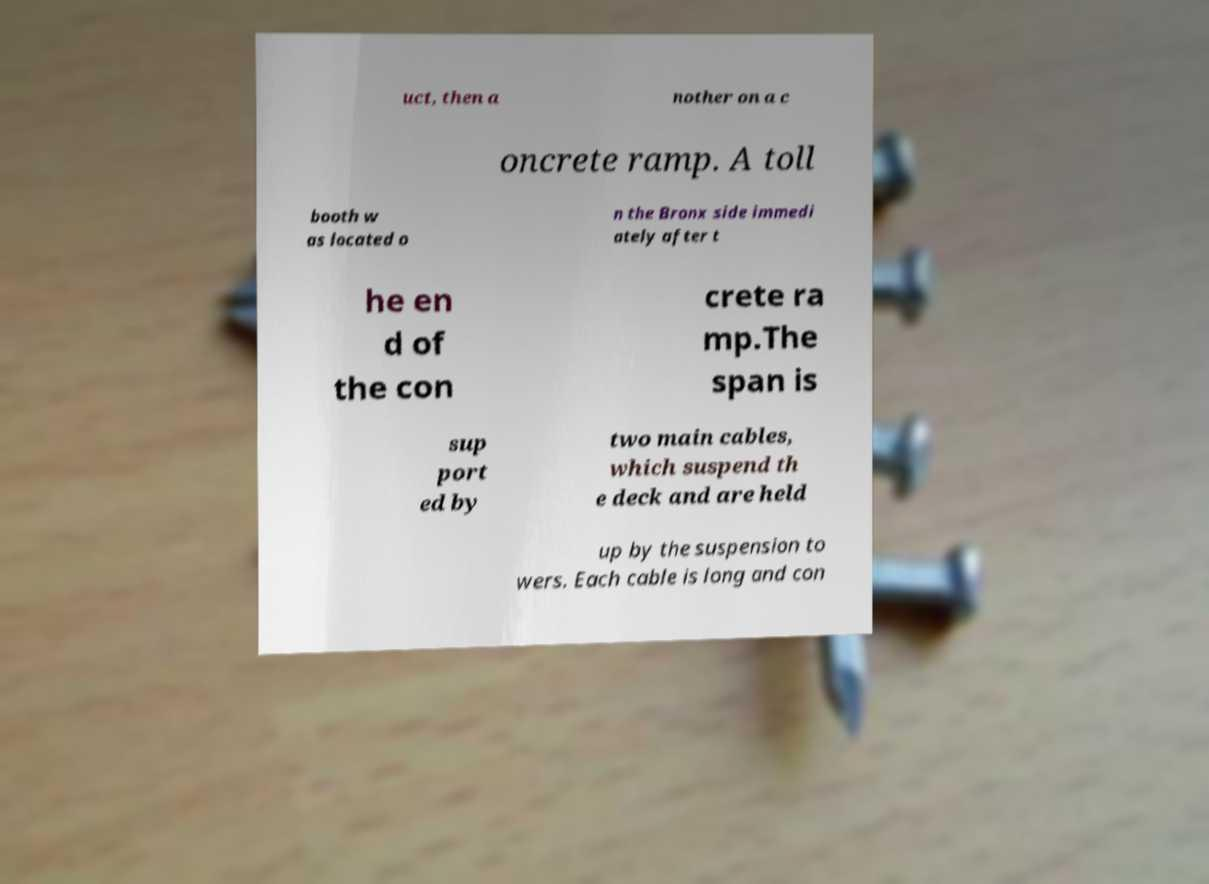Could you assist in decoding the text presented in this image and type it out clearly? uct, then a nother on a c oncrete ramp. A toll booth w as located o n the Bronx side immedi ately after t he en d of the con crete ra mp.The span is sup port ed by two main cables, which suspend th e deck and are held up by the suspension to wers. Each cable is long and con 